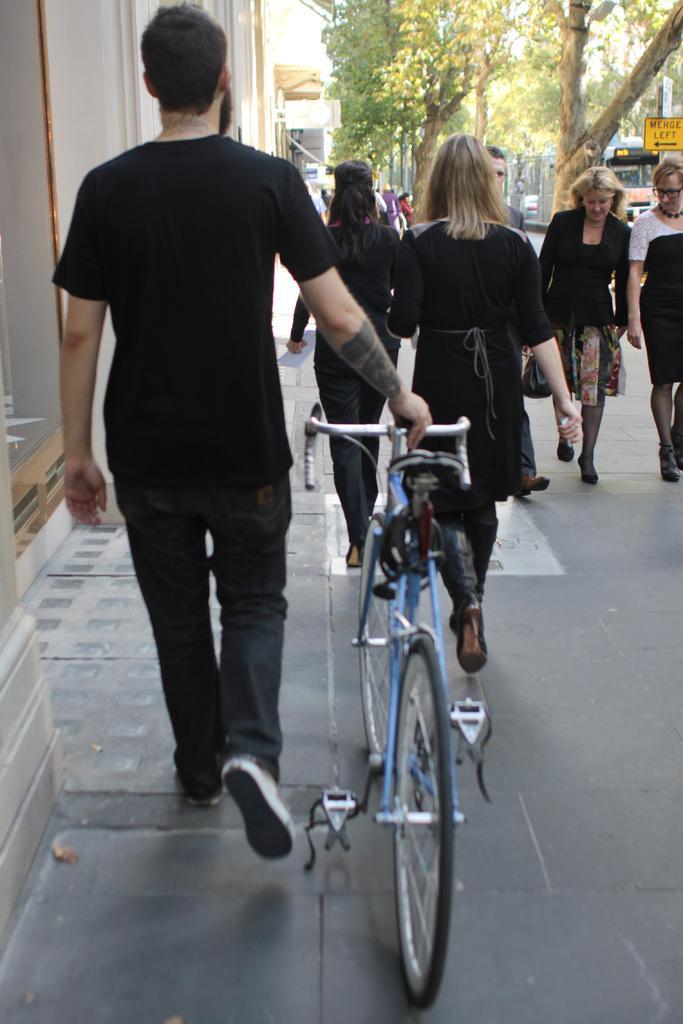Describe this image in one or two sentences. In this image I can see few people are walking in front of the buildings, among one person is holding bicycles and walking, side there are some trees and I can see a train on the track. 